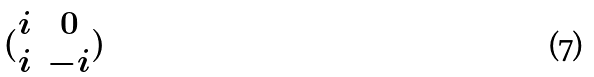Convert formula to latex. <formula><loc_0><loc_0><loc_500><loc_500>( \begin{matrix} i & 0 \\ i & - i \end{matrix} )</formula> 